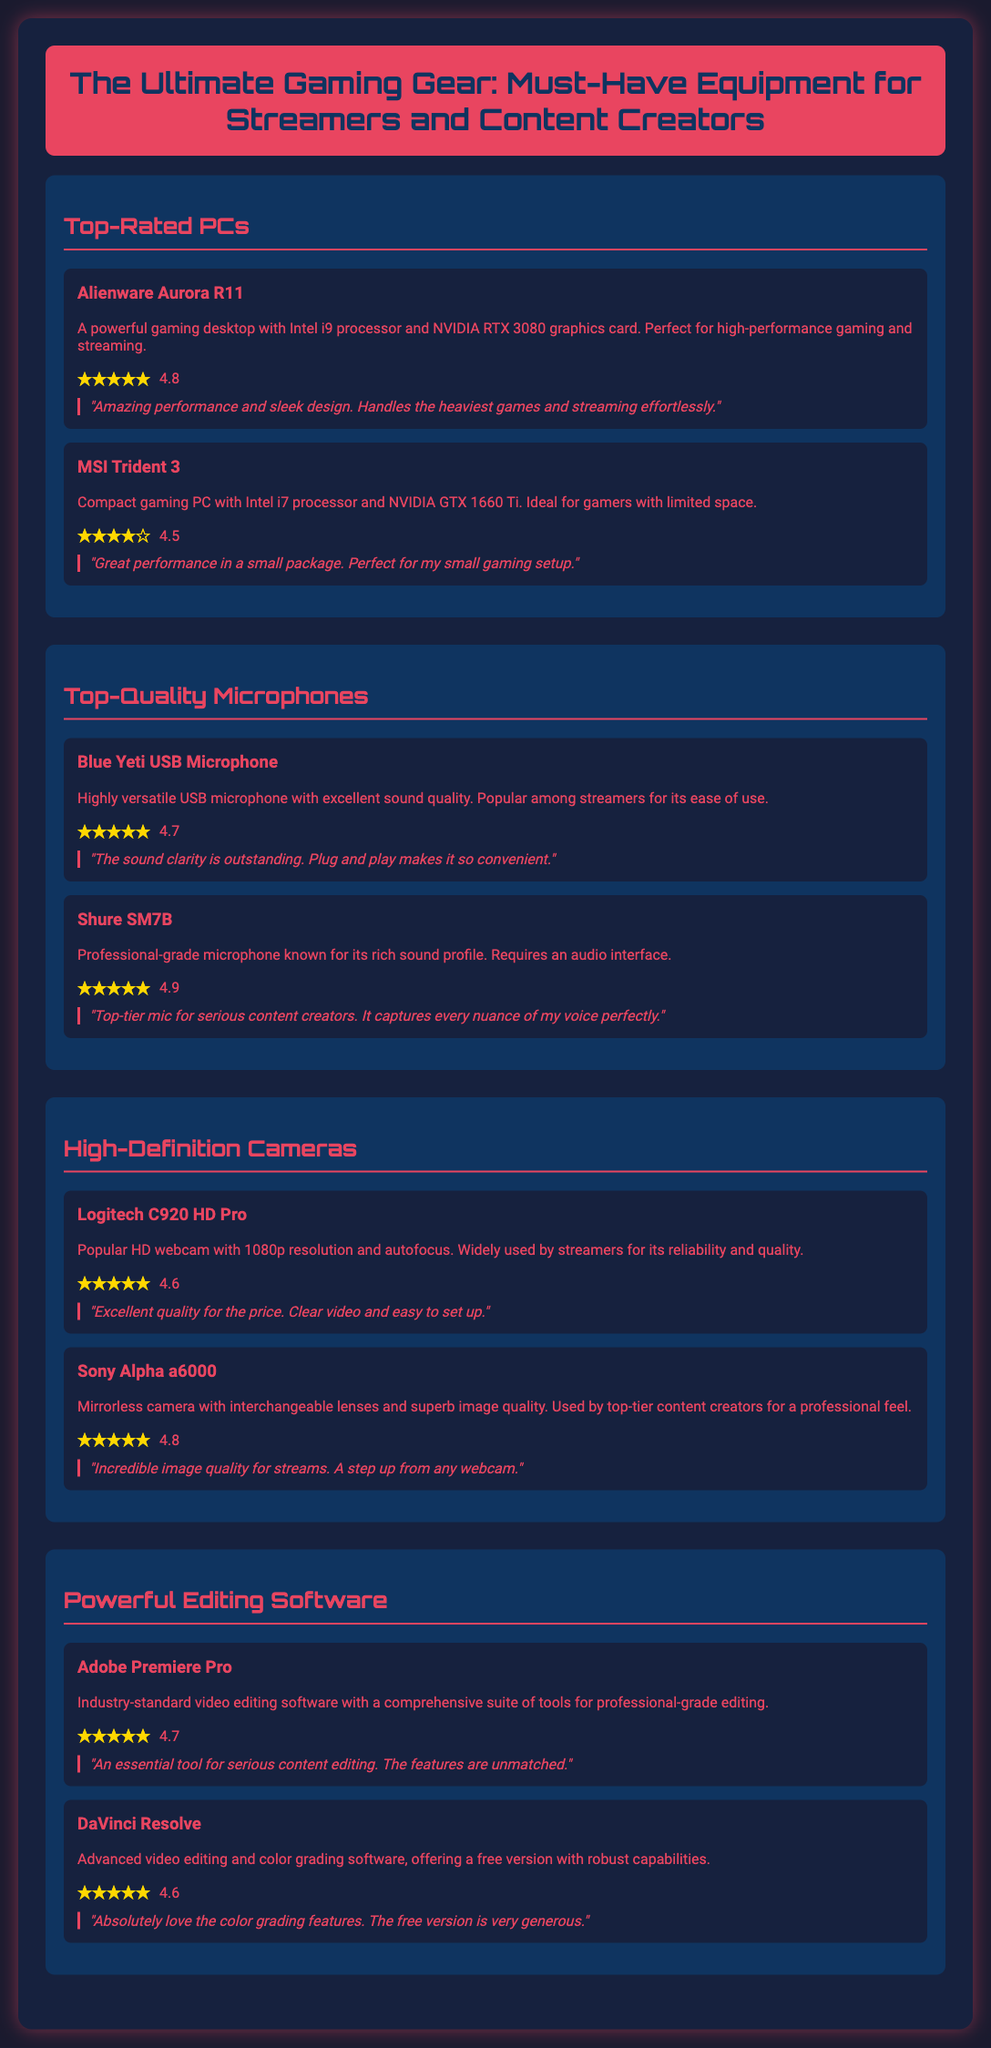What is the rating of the Alienware Aurora R11? The rating is presented as a star rating, which is 4.8 out of 5 stars.
Answer: 4.8 Which camera is known for its 1080p resolution? The Logitech C920 HD Pro is identified as a popular HD webcam with 1080p resolution.
Answer: Logitech C920 HD Pro What is the primary feature of the Blue Yeti USB Microphone? It is noted for its excellent sound quality and versatility.
Answer: Excellent sound quality What star rating does DaVinci Resolve have? The star rating for DaVinci Resolve is indicated as 4.6.
Answer: 4.6 Which PC is ideal for gamers with limited space? The MSI Trident 3 is described as a compact gaming PC suitable for small spaces.
Answer: MSI Trident 3 Which microphone has the highest star rating? The Shure SM7B received a star rating of 4.9, making it the highest rated microphone.
Answer: 4.9 What editing software is considered industry-standard? Adobe Premiere Pro is recognized as the industry-standard video editing software.
Answer: Adobe Premiere Pro How many items are listed under Top-Quality Microphones? There are two items listed under Top-Quality Microphones.
Answer: Two items What is the rating of the Sony Alpha a6000 camera? The Sony Alpha a6000 has a star rating of 4.8.
Answer: 4.8 